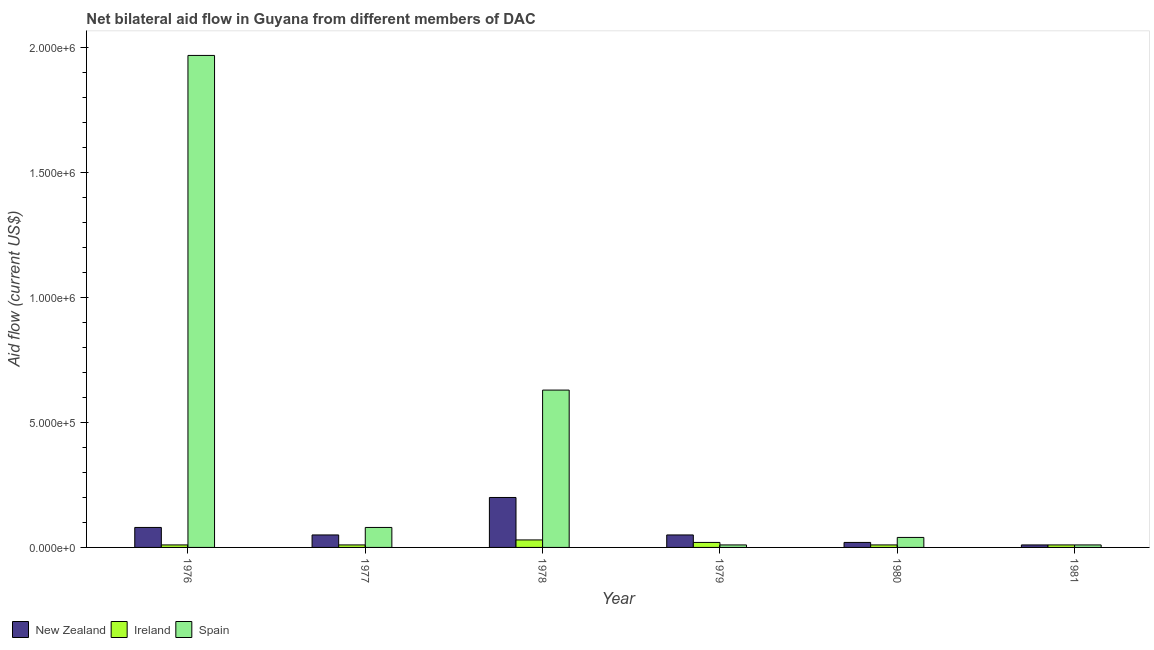How many different coloured bars are there?
Provide a succinct answer. 3. How many groups of bars are there?
Offer a terse response. 6. Are the number of bars per tick equal to the number of legend labels?
Offer a terse response. Yes. How many bars are there on the 3rd tick from the left?
Your answer should be very brief. 3. How many bars are there on the 2nd tick from the right?
Your answer should be very brief. 3. What is the label of the 3rd group of bars from the left?
Your answer should be very brief. 1978. What is the amount of aid provided by new zealand in 1980?
Keep it short and to the point. 2.00e+04. Across all years, what is the maximum amount of aid provided by new zealand?
Your answer should be very brief. 2.00e+05. Across all years, what is the minimum amount of aid provided by spain?
Provide a succinct answer. 10000. In which year was the amount of aid provided by spain maximum?
Make the answer very short. 1976. In which year was the amount of aid provided by spain minimum?
Provide a succinct answer. 1979. What is the total amount of aid provided by ireland in the graph?
Give a very brief answer. 9.00e+04. What is the difference between the amount of aid provided by new zealand in 1977 and that in 1980?
Your response must be concise. 3.00e+04. What is the difference between the amount of aid provided by new zealand in 1978 and the amount of aid provided by ireland in 1977?
Your answer should be very brief. 1.50e+05. What is the average amount of aid provided by spain per year?
Ensure brevity in your answer.  4.57e+05. In how many years, is the amount of aid provided by new zealand greater than 300000 US$?
Offer a terse response. 0. What is the ratio of the amount of aid provided by spain in 1977 to that in 1980?
Offer a very short reply. 2. What is the difference between the highest and the lowest amount of aid provided by spain?
Provide a succinct answer. 1.96e+06. In how many years, is the amount of aid provided by spain greater than the average amount of aid provided by spain taken over all years?
Ensure brevity in your answer.  2. Is the sum of the amount of aid provided by spain in 1978 and 1981 greater than the maximum amount of aid provided by new zealand across all years?
Your answer should be very brief. No. What is the difference between two consecutive major ticks on the Y-axis?
Provide a succinct answer. 5.00e+05. How many legend labels are there?
Offer a terse response. 3. How are the legend labels stacked?
Provide a succinct answer. Horizontal. What is the title of the graph?
Provide a succinct answer. Net bilateral aid flow in Guyana from different members of DAC. Does "Travel services" appear as one of the legend labels in the graph?
Make the answer very short. No. What is the label or title of the X-axis?
Ensure brevity in your answer.  Year. What is the Aid flow (current US$) in New Zealand in 1976?
Your response must be concise. 8.00e+04. What is the Aid flow (current US$) in Spain in 1976?
Keep it short and to the point. 1.97e+06. What is the Aid flow (current US$) of New Zealand in 1978?
Provide a succinct answer. 2.00e+05. What is the Aid flow (current US$) of Spain in 1978?
Provide a short and direct response. 6.30e+05. What is the Aid flow (current US$) in New Zealand in 1979?
Keep it short and to the point. 5.00e+04. What is the Aid flow (current US$) in Spain in 1979?
Make the answer very short. 10000. What is the Aid flow (current US$) in New Zealand in 1980?
Offer a very short reply. 2.00e+04. What is the Aid flow (current US$) of Ireland in 1981?
Offer a terse response. 10000. Across all years, what is the maximum Aid flow (current US$) of New Zealand?
Keep it short and to the point. 2.00e+05. Across all years, what is the maximum Aid flow (current US$) in Ireland?
Your response must be concise. 3.00e+04. Across all years, what is the maximum Aid flow (current US$) of Spain?
Keep it short and to the point. 1.97e+06. Across all years, what is the minimum Aid flow (current US$) of Spain?
Your response must be concise. 10000. What is the total Aid flow (current US$) in New Zealand in the graph?
Give a very brief answer. 4.10e+05. What is the total Aid flow (current US$) in Ireland in the graph?
Ensure brevity in your answer.  9.00e+04. What is the total Aid flow (current US$) of Spain in the graph?
Give a very brief answer. 2.74e+06. What is the difference between the Aid flow (current US$) of Ireland in 1976 and that in 1977?
Keep it short and to the point. 0. What is the difference between the Aid flow (current US$) of Spain in 1976 and that in 1977?
Provide a short and direct response. 1.89e+06. What is the difference between the Aid flow (current US$) of Ireland in 1976 and that in 1978?
Give a very brief answer. -2.00e+04. What is the difference between the Aid flow (current US$) of Spain in 1976 and that in 1978?
Give a very brief answer. 1.34e+06. What is the difference between the Aid flow (current US$) of New Zealand in 1976 and that in 1979?
Your response must be concise. 3.00e+04. What is the difference between the Aid flow (current US$) in Spain in 1976 and that in 1979?
Your answer should be very brief. 1.96e+06. What is the difference between the Aid flow (current US$) of Ireland in 1976 and that in 1980?
Offer a very short reply. 0. What is the difference between the Aid flow (current US$) in Spain in 1976 and that in 1980?
Keep it short and to the point. 1.93e+06. What is the difference between the Aid flow (current US$) of New Zealand in 1976 and that in 1981?
Offer a very short reply. 7.00e+04. What is the difference between the Aid flow (current US$) in Spain in 1976 and that in 1981?
Provide a succinct answer. 1.96e+06. What is the difference between the Aid flow (current US$) in New Zealand in 1977 and that in 1978?
Make the answer very short. -1.50e+05. What is the difference between the Aid flow (current US$) in Spain in 1977 and that in 1978?
Your response must be concise. -5.50e+05. What is the difference between the Aid flow (current US$) of New Zealand in 1977 and that in 1979?
Your answer should be compact. 0. What is the difference between the Aid flow (current US$) in Spain in 1977 and that in 1979?
Ensure brevity in your answer.  7.00e+04. What is the difference between the Aid flow (current US$) of New Zealand in 1977 and that in 1980?
Offer a terse response. 3.00e+04. What is the difference between the Aid flow (current US$) in Ireland in 1977 and that in 1980?
Keep it short and to the point. 0. What is the difference between the Aid flow (current US$) of Spain in 1977 and that in 1980?
Give a very brief answer. 4.00e+04. What is the difference between the Aid flow (current US$) of New Zealand in 1977 and that in 1981?
Your answer should be very brief. 4.00e+04. What is the difference between the Aid flow (current US$) in New Zealand in 1978 and that in 1979?
Your response must be concise. 1.50e+05. What is the difference between the Aid flow (current US$) in Ireland in 1978 and that in 1979?
Your answer should be compact. 10000. What is the difference between the Aid flow (current US$) of Spain in 1978 and that in 1979?
Make the answer very short. 6.20e+05. What is the difference between the Aid flow (current US$) in Spain in 1978 and that in 1980?
Offer a terse response. 5.90e+05. What is the difference between the Aid flow (current US$) in New Zealand in 1978 and that in 1981?
Keep it short and to the point. 1.90e+05. What is the difference between the Aid flow (current US$) of Ireland in 1978 and that in 1981?
Your response must be concise. 2.00e+04. What is the difference between the Aid flow (current US$) in Spain in 1978 and that in 1981?
Your response must be concise. 6.20e+05. What is the difference between the Aid flow (current US$) of Ireland in 1979 and that in 1980?
Your answer should be very brief. 10000. What is the difference between the Aid flow (current US$) of Ireland in 1979 and that in 1981?
Give a very brief answer. 10000. What is the difference between the Aid flow (current US$) of New Zealand in 1980 and that in 1981?
Ensure brevity in your answer.  10000. What is the difference between the Aid flow (current US$) in New Zealand in 1976 and the Aid flow (current US$) in Spain in 1978?
Your answer should be compact. -5.50e+05. What is the difference between the Aid flow (current US$) in Ireland in 1976 and the Aid flow (current US$) in Spain in 1978?
Ensure brevity in your answer.  -6.20e+05. What is the difference between the Aid flow (current US$) in New Zealand in 1976 and the Aid flow (current US$) in Ireland in 1979?
Give a very brief answer. 6.00e+04. What is the difference between the Aid flow (current US$) in New Zealand in 1976 and the Aid flow (current US$) in Spain in 1979?
Your answer should be very brief. 7.00e+04. What is the difference between the Aid flow (current US$) of New Zealand in 1977 and the Aid flow (current US$) of Ireland in 1978?
Give a very brief answer. 2.00e+04. What is the difference between the Aid flow (current US$) of New Zealand in 1977 and the Aid flow (current US$) of Spain in 1978?
Your answer should be very brief. -5.80e+05. What is the difference between the Aid flow (current US$) of Ireland in 1977 and the Aid flow (current US$) of Spain in 1978?
Give a very brief answer. -6.20e+05. What is the difference between the Aid flow (current US$) in New Zealand in 1977 and the Aid flow (current US$) in Ireland in 1979?
Provide a succinct answer. 3.00e+04. What is the difference between the Aid flow (current US$) in Ireland in 1977 and the Aid flow (current US$) in Spain in 1979?
Ensure brevity in your answer.  0. What is the difference between the Aid flow (current US$) in Ireland in 1977 and the Aid flow (current US$) in Spain in 1980?
Your answer should be very brief. -3.00e+04. What is the difference between the Aid flow (current US$) in New Zealand in 1977 and the Aid flow (current US$) in Ireland in 1981?
Give a very brief answer. 4.00e+04. What is the difference between the Aid flow (current US$) of New Zealand in 1977 and the Aid flow (current US$) of Spain in 1981?
Your answer should be very brief. 4.00e+04. What is the difference between the Aid flow (current US$) of New Zealand in 1978 and the Aid flow (current US$) of Spain in 1980?
Give a very brief answer. 1.60e+05. What is the difference between the Aid flow (current US$) of Ireland in 1978 and the Aid flow (current US$) of Spain in 1980?
Your response must be concise. -10000. What is the difference between the Aid flow (current US$) in New Zealand in 1978 and the Aid flow (current US$) in Spain in 1981?
Ensure brevity in your answer.  1.90e+05. What is the difference between the Aid flow (current US$) in Ireland in 1978 and the Aid flow (current US$) in Spain in 1981?
Provide a succinct answer. 2.00e+04. What is the difference between the Aid flow (current US$) in New Zealand in 1979 and the Aid flow (current US$) in Ireland in 1981?
Give a very brief answer. 4.00e+04. What is the difference between the Aid flow (current US$) in New Zealand in 1980 and the Aid flow (current US$) in Spain in 1981?
Make the answer very short. 10000. What is the difference between the Aid flow (current US$) of Ireland in 1980 and the Aid flow (current US$) of Spain in 1981?
Give a very brief answer. 0. What is the average Aid flow (current US$) in New Zealand per year?
Provide a short and direct response. 6.83e+04. What is the average Aid flow (current US$) in Ireland per year?
Your answer should be compact. 1.50e+04. What is the average Aid flow (current US$) of Spain per year?
Give a very brief answer. 4.57e+05. In the year 1976, what is the difference between the Aid flow (current US$) in New Zealand and Aid flow (current US$) in Spain?
Your answer should be compact. -1.89e+06. In the year 1976, what is the difference between the Aid flow (current US$) in Ireland and Aid flow (current US$) in Spain?
Your answer should be very brief. -1.96e+06. In the year 1977, what is the difference between the Aid flow (current US$) in New Zealand and Aid flow (current US$) in Ireland?
Make the answer very short. 4.00e+04. In the year 1978, what is the difference between the Aid flow (current US$) in New Zealand and Aid flow (current US$) in Ireland?
Ensure brevity in your answer.  1.70e+05. In the year 1978, what is the difference between the Aid flow (current US$) of New Zealand and Aid flow (current US$) of Spain?
Your answer should be very brief. -4.30e+05. In the year 1978, what is the difference between the Aid flow (current US$) of Ireland and Aid flow (current US$) of Spain?
Give a very brief answer. -6.00e+05. In the year 1979, what is the difference between the Aid flow (current US$) in New Zealand and Aid flow (current US$) in Ireland?
Give a very brief answer. 3.00e+04. In the year 1979, what is the difference between the Aid flow (current US$) of New Zealand and Aid flow (current US$) of Spain?
Ensure brevity in your answer.  4.00e+04. In the year 1980, what is the difference between the Aid flow (current US$) of Ireland and Aid flow (current US$) of Spain?
Provide a short and direct response. -3.00e+04. In the year 1981, what is the difference between the Aid flow (current US$) of New Zealand and Aid flow (current US$) of Ireland?
Offer a very short reply. 0. What is the ratio of the Aid flow (current US$) in New Zealand in 1976 to that in 1977?
Your response must be concise. 1.6. What is the ratio of the Aid flow (current US$) of Ireland in 1976 to that in 1977?
Provide a short and direct response. 1. What is the ratio of the Aid flow (current US$) of Spain in 1976 to that in 1977?
Offer a terse response. 24.62. What is the ratio of the Aid flow (current US$) of New Zealand in 1976 to that in 1978?
Make the answer very short. 0.4. What is the ratio of the Aid flow (current US$) of Spain in 1976 to that in 1978?
Provide a succinct answer. 3.13. What is the ratio of the Aid flow (current US$) of New Zealand in 1976 to that in 1979?
Provide a succinct answer. 1.6. What is the ratio of the Aid flow (current US$) in Ireland in 1976 to that in 1979?
Provide a succinct answer. 0.5. What is the ratio of the Aid flow (current US$) of Spain in 1976 to that in 1979?
Make the answer very short. 197. What is the ratio of the Aid flow (current US$) of New Zealand in 1976 to that in 1980?
Offer a terse response. 4. What is the ratio of the Aid flow (current US$) in Ireland in 1976 to that in 1980?
Offer a very short reply. 1. What is the ratio of the Aid flow (current US$) in Spain in 1976 to that in 1980?
Offer a terse response. 49.25. What is the ratio of the Aid flow (current US$) in Spain in 1976 to that in 1981?
Offer a terse response. 197. What is the ratio of the Aid flow (current US$) in Ireland in 1977 to that in 1978?
Provide a short and direct response. 0.33. What is the ratio of the Aid flow (current US$) of Spain in 1977 to that in 1978?
Make the answer very short. 0.13. What is the ratio of the Aid flow (current US$) of New Zealand in 1977 to that in 1980?
Give a very brief answer. 2.5. What is the ratio of the Aid flow (current US$) of Ireland in 1977 to that in 1980?
Offer a very short reply. 1. What is the ratio of the Aid flow (current US$) in Spain in 1977 to that in 1980?
Offer a very short reply. 2. What is the ratio of the Aid flow (current US$) of New Zealand in 1977 to that in 1981?
Keep it short and to the point. 5. What is the ratio of the Aid flow (current US$) in Spain in 1977 to that in 1981?
Offer a terse response. 8. What is the ratio of the Aid flow (current US$) of New Zealand in 1978 to that in 1979?
Provide a succinct answer. 4. What is the ratio of the Aid flow (current US$) in Ireland in 1978 to that in 1979?
Your answer should be very brief. 1.5. What is the ratio of the Aid flow (current US$) of Spain in 1978 to that in 1979?
Your answer should be compact. 63. What is the ratio of the Aid flow (current US$) in Ireland in 1978 to that in 1980?
Your answer should be compact. 3. What is the ratio of the Aid flow (current US$) in Spain in 1978 to that in 1980?
Ensure brevity in your answer.  15.75. What is the ratio of the Aid flow (current US$) in New Zealand in 1978 to that in 1981?
Provide a succinct answer. 20. What is the ratio of the Aid flow (current US$) of New Zealand in 1979 to that in 1980?
Keep it short and to the point. 2.5. What is the ratio of the Aid flow (current US$) of New Zealand in 1979 to that in 1981?
Ensure brevity in your answer.  5. What is the ratio of the Aid flow (current US$) of New Zealand in 1980 to that in 1981?
Your answer should be compact. 2. What is the difference between the highest and the second highest Aid flow (current US$) of New Zealand?
Offer a very short reply. 1.20e+05. What is the difference between the highest and the second highest Aid flow (current US$) in Ireland?
Your response must be concise. 10000. What is the difference between the highest and the second highest Aid flow (current US$) in Spain?
Your response must be concise. 1.34e+06. What is the difference between the highest and the lowest Aid flow (current US$) of New Zealand?
Your answer should be compact. 1.90e+05. What is the difference between the highest and the lowest Aid flow (current US$) of Ireland?
Your answer should be compact. 2.00e+04. What is the difference between the highest and the lowest Aid flow (current US$) of Spain?
Provide a short and direct response. 1.96e+06. 